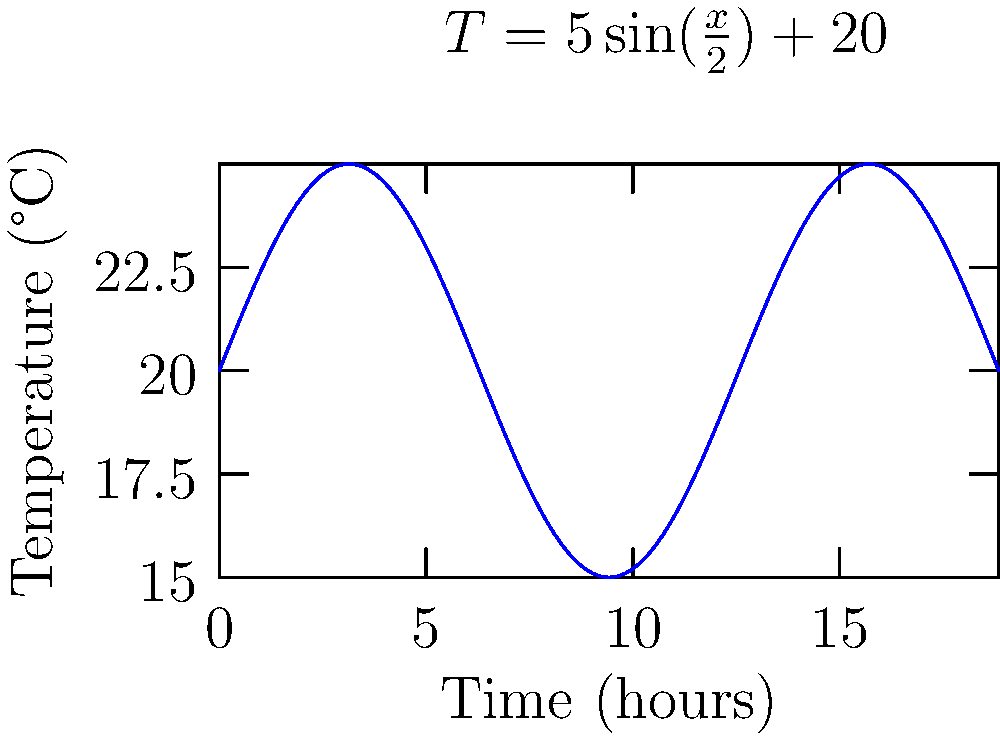A wildlife habitat experiences temperature fluctuations throughout the day, represented by the function $T(x) = 5\sin(\frac{x}{2}) + 20$, where $T$ is the temperature in °C and $x$ is the time in hours. Calculate the total heat exposure (in °C-hours) for the wildlife in this habitat over a 24-hour period. Round your answer to the nearest whole number. To solve this problem, we need to find the area under the curve of the temperature function over a 24-hour period. This can be done using a definite integral.

Step 1: Set up the integral
The integral will be from $x = 0$ to $x = 24$ (representing 24 hours):
$$\int_0^{24} (5\sin(\frac{x}{2}) + 20) dx$$

Step 2: Integrate the function
$$\int (5\sin(\frac{x}{2}) + 20) dx = -10\cos(\frac{x}{2}) + 20x + C$$

Step 3: Apply the limits of integration
$$[-10\cos(\frac{x}{2}) + 20x]_0^{24}$$

Step 4: Evaluate
$$(-10\cos(12) + 20(24)) - (-10\cos(0) + 20(0))$$
$$= (-10\cos(12) + 480) - (-10 + 0)$$
$$= -10\cos(12) + 480 + 10$$

Step 5: Calculate the final result
$$= -10(-0.8440) + 490 = 498.440$$

Step 6: Round to the nearest whole number
498 °C-hours
Answer: 498 °C-hours 